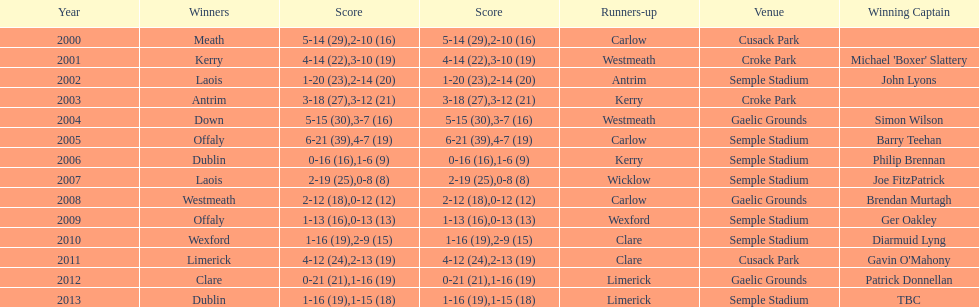Which team was the previous winner before dublin in 2013? Clare. 